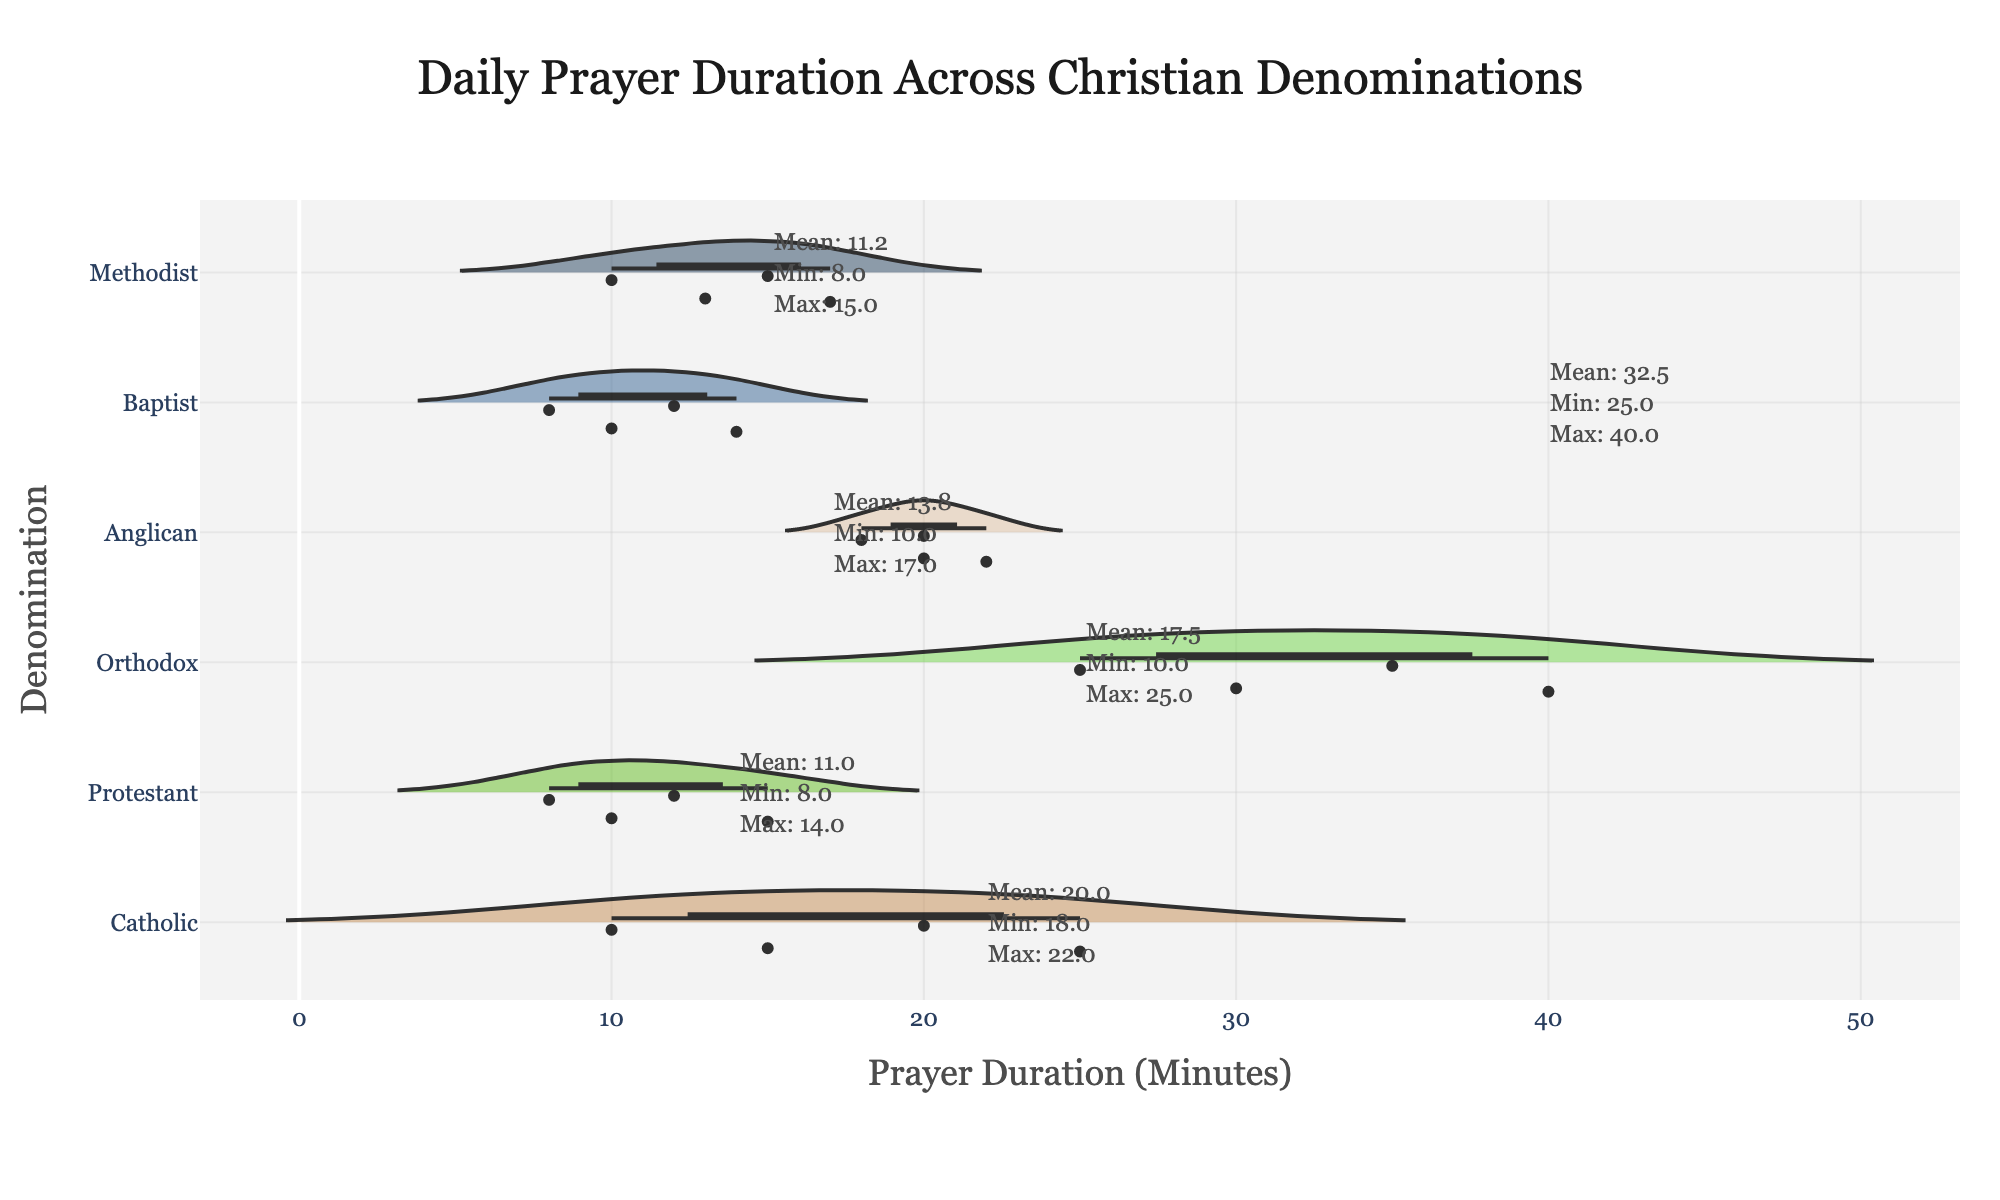what does the title of the figure indicate? The title of the figure points out that the chart represents the daily prayer duration across different Christian denominations.
Answer: Daily Prayer Duration Across Christian Denominations What measurement is represented on the x-axis? The x-axis title indicates that the measurement represented is the duration of prayer in minutes.
Answer: Prayer Duration (Minutes) Which denomination shows the highest maximum prayer duration? By looking at the horizontal spread of the violin plots, the Orthodox denomination has the longest spread extending to the highest value.
Answer: Orthodox What is the mean prayer duration for Methodists? The annotation near the Methodist plot provides the mean duration as 13.8 minutes.
Answer: 13.8 How does the variability in prayer durations compare between Catholics and Baptists? Catholics have a prayer duration range from 10 to 25 minutes, whereas Baptists range from 8 to 14 minutes, indicating lesser variability among Baptists.
Answer: Catholics have higher variability than Baptists Which denomination has the most consistently close prayer durations based on the plot? Observing the density and spread of the violin plots, Baptists show a very compressed plot with a smaller range and higher density, indicating consistency.
Answer: Baptists Does any denomination have more than one mode (multi-modal distribution) in their prayer durations? A multi-modal distribution would have multiple peaks. None of the distributions show clear multiple peaks, indicating they are likely unimodal.
Answer: No What are the minimum and maximum prayer durations for the Anglican denomination? According to the annotations near the Anglican plot, the minimum and maximum durations are 18 and 22 minutes, respectively.
Answer: 18 and 22 Which denomination has the closest mean prayer duration to that of Protestants? Comparing the mean prayer durations shown in the annotations, the Methodists' mean (13.8) is closest to Protestants' mean (11.3).
Answer: Methodists How does the length of the longest prayer in Catholicism compare to that of the Orthodox denomination? Catholics have a maximum duration of 25 minutes, while the Orthodox have a maximum duration of 40 minutes, so Orthodox prayers reach significantly higher durations.
Answer: Orthodox prayers are longer 